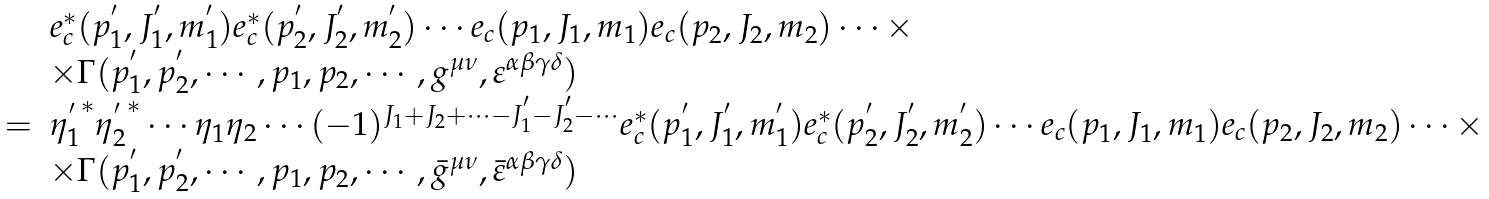Convert formula to latex. <formula><loc_0><loc_0><loc_500><loc_500>\begin{array} { r l } & e ^ { \ast } _ { c } ( p _ { 1 } ^ { ^ { \prime } } , J _ { 1 } ^ { ^ { \prime } } , m _ { 1 } ^ { ^ { \prime } } ) e ^ { \ast } _ { c } ( p _ { 2 } ^ { ^ { \prime } } , J _ { 2 } ^ { ^ { \prime } } , m _ { 2 } ^ { ^ { \prime } } ) \cdots e _ { c } ( p _ { 1 } , J _ { 1 } , m _ { 1 } ) e _ { c } ( p _ { 2 } , J _ { 2 } , m _ { 2 } ) \cdots \times \\ & \times \Gamma ( p _ { 1 } ^ { ^ { \prime } } , p _ { 2 } ^ { ^ { \prime } } , \cdots , p _ { 1 } , p _ { 2 } , \cdots , g ^ { \mu \nu } , \varepsilon ^ { \alpha \beta \gamma \delta } ) \\ = & { \eta _ { 1 } ^ { ^ { \prime } } } ^ { \ast } { \eta _ { 2 } ^ { ^ { \prime } } } ^ { \ast } \cdots \eta _ { 1 } \eta _ { 2 } \cdots ( - 1 ) ^ { J _ { 1 } + J _ { 2 } + \cdots - J _ { 1 } ^ { ^ { \prime } } - J _ { 2 } ^ { ^ { \prime } } - \cdots } e ^ { \ast } _ { c } ( p _ { 1 } ^ { ^ { \prime } } , J _ { 1 } ^ { ^ { \prime } } , m _ { 1 } ^ { ^ { \prime } } ) e ^ { \ast } _ { c } ( p _ { 2 } ^ { ^ { \prime } } , J _ { 2 } ^ { ^ { \prime } } , m _ { 2 } ^ { ^ { \prime } } ) \cdots e _ { c } ( p _ { 1 } , J _ { 1 } , m _ { 1 } ) e _ { c } ( p _ { 2 } , J _ { 2 } , m _ { 2 } ) \cdots \times \\ & \times \Gamma ( p _ { 1 } ^ { ^ { \prime } } , p _ { 2 } ^ { ^ { \prime } } , \cdots , p _ { 1 } , p _ { 2 } , \cdots , \bar { g } ^ { \mu \nu } , \bar { \varepsilon } ^ { \alpha \beta \gamma \delta } ) \end{array}</formula> 